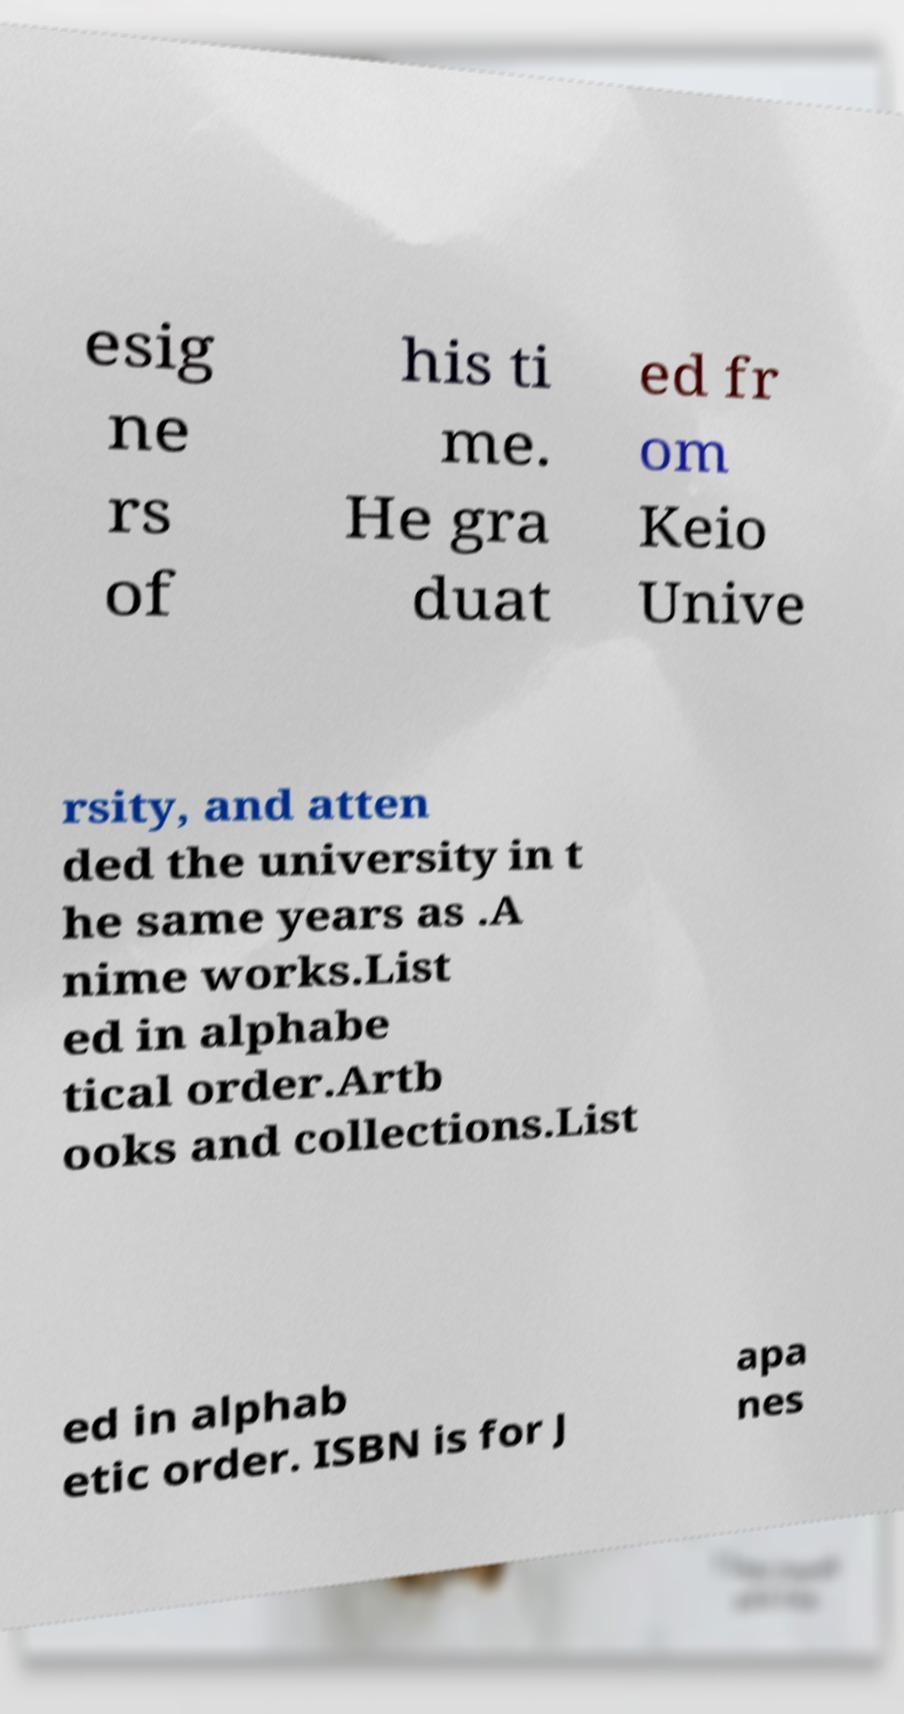I need the written content from this picture converted into text. Can you do that? esig ne rs of his ti me. He gra duat ed fr om Keio Unive rsity, and atten ded the university in t he same years as .A nime works.List ed in alphabe tical order.Artb ooks and collections.List ed in alphab etic order. ISBN is for J apa nes 